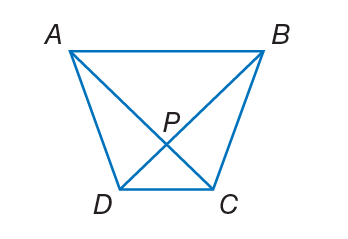Answer the mathemtical geometry problem and directly provide the correct option letter.
Question: A B C D is a trapezoid. If m \angle A B C = 4 x + 11 and m \angle D A B = 2 x + 33, find the value of x so that A B C D is isosceles.
Choices: A: 11 B: 30 C: 44 D: 55 A 